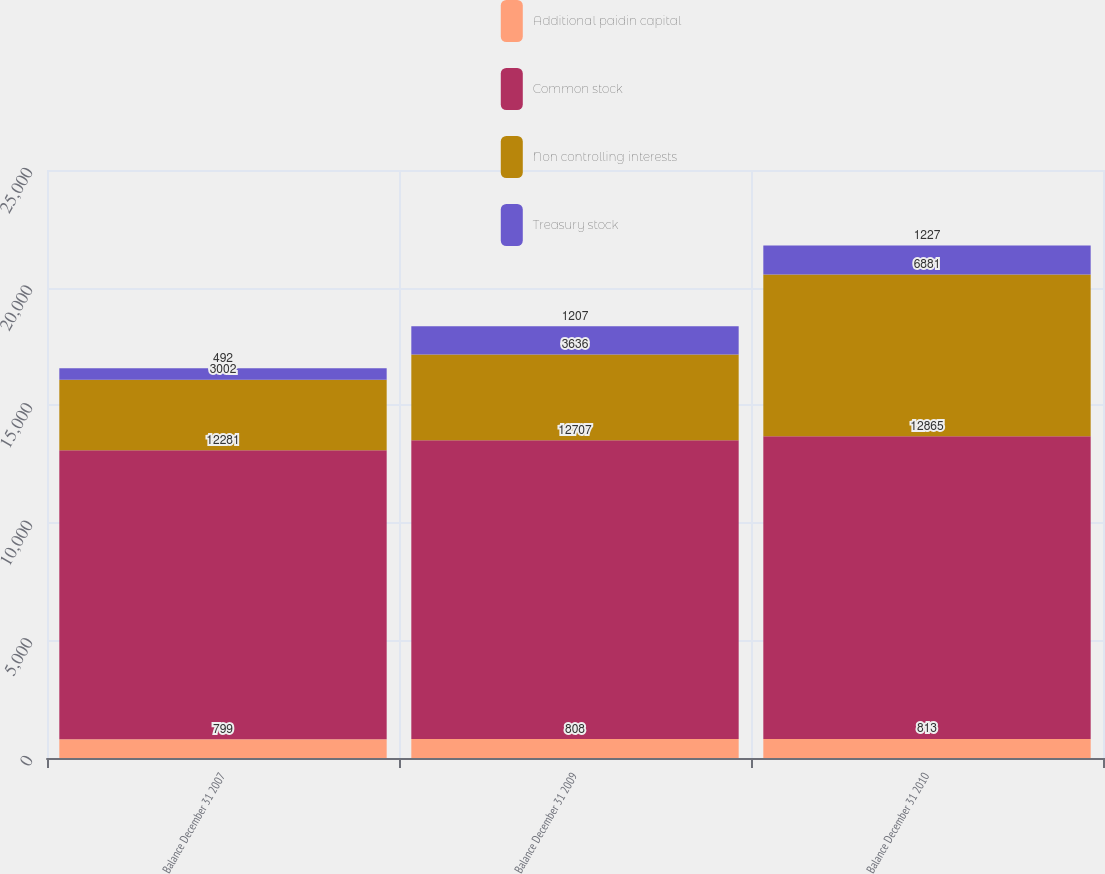<chart> <loc_0><loc_0><loc_500><loc_500><stacked_bar_chart><ecel><fcel>Balance December 31 2007<fcel>Balance December 31 2009<fcel>Balance December 31 2010<nl><fcel>Additional paidin capital<fcel>799<fcel>808<fcel>813<nl><fcel>Common stock<fcel>12281<fcel>12707<fcel>12865<nl><fcel>Non controlling interests<fcel>3002<fcel>3636<fcel>6881<nl><fcel>Treasury stock<fcel>492<fcel>1207<fcel>1227<nl></chart> 